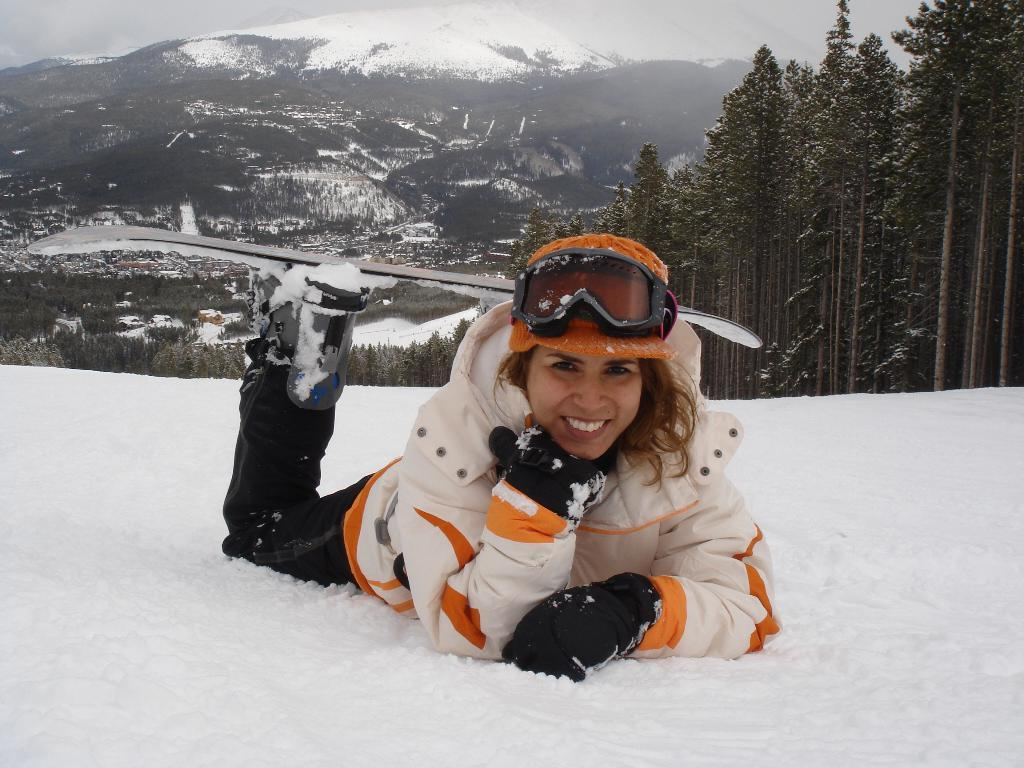What is the woman doing in the image? The woman is lying on the snow in the image. What is the woman's facial expression in the image? The woman is smiling in the image. What can be seen in the background of the image? There is a mountain, trees, and the sky visible in the background of the image. How many cows are present in the image? There are no cows present in the image. What level of experience does the woman have with snow, as indicated by her pose? The image does not provide information about the woman's experience level with snow. 